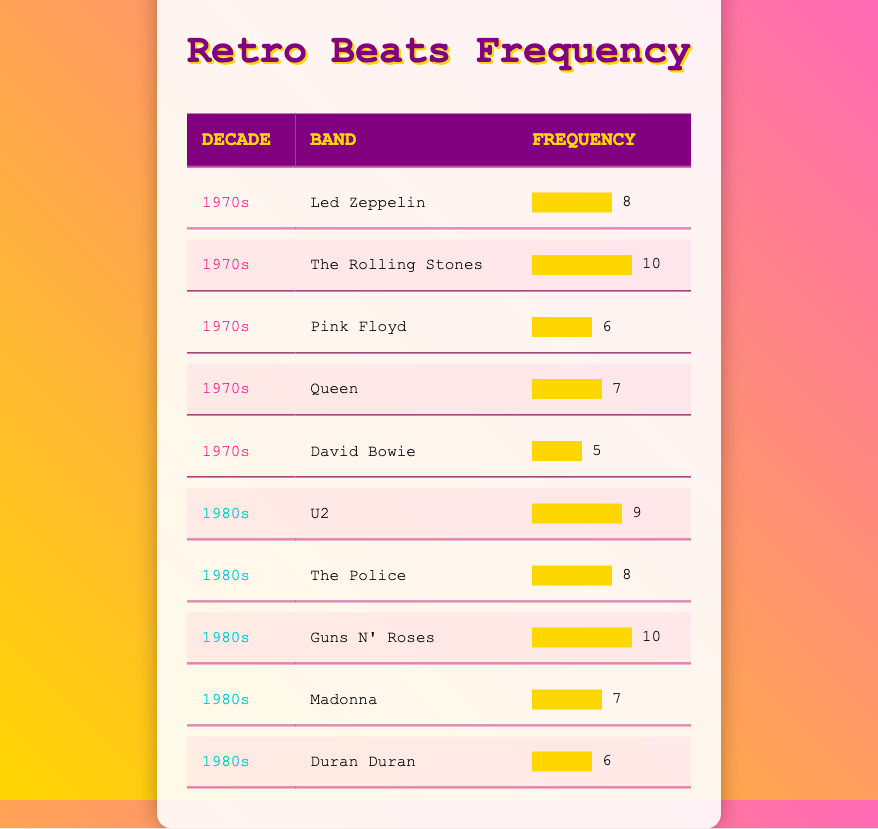What is the band with the highest frequency in the 1970s? In the 1970s section of the table, I can see that The Rolling Stones has the highest frequency value of 10.
Answer: The Rolling Stones How many bands from the 1980s have a frequency of 7 or more? The bands from the 1980s listed are U2, The Police, Guns N' Roses, Madonna, and Duran Duran. Among these, U2 (9), The Police (8), Guns N' Roses (10), and Madonna (7) have frequencies of 7 or more. That's a total of 4 bands.
Answer: 4 Which decade has more bands with a frequency of 6 or higher? From the 1970s, Led Zeppelin (8), The Rolling Stones (10), Pink Floyd (6), Queen (7), and David Bowie (5) give us 4 bands with 6 or higher. For the 1980s, U2 (9), The Police (8), Guns N' Roses (10), Madonna (7), and Duran Duran (6) also yields 5 bands. Thus, the 1980s have more bands with a frequency of 6 or higher.
Answer: The 1980s Is there a band from the 1970s with the same frequency as any band from the 1980s? The 1970s have Led Zeppelin (8), The Rolling Stones (10), Pink Floyd (6), Queen (7), and David Bowie (5). The 1980s have U2 (9), The Police (8), Guns N' Roses (10), Madonna (7), and Duran Duran (6). Notably, Led Zeppelin and The Police both have a frequency of 8, and The Rolling Stones and Guns N' Roses both have a frequency of 10. Therefore, there are indeed matches.
Answer: Yes What is the total frequency of all the bands from the 1970s? To find the total frequency of all bands in the 1970s, I sum Led Zeppelin (8), The Rolling Stones (10), Pink Floyd (6), Queen (7), and David Bowie (5). The total is 8 + 10 + 6 + 7 + 5 = 36.
Answer: 36 Which band from the 1980s has the lowest frequency? Investigating the 1980s section, I see the bands listed are U2 (9), The Police (8), Guns N' Roses (10), Madonna (7), and Duran Duran (6). The band with the lowest frequency among them is Duran Duran, which has a frequency of 6.
Answer: Duran Duran How many overall frequencies from both decades are above 8? Summing up the frequencies for both decades, from the 1970s: The Rolling Stones (10), Led Zeppelin (8), and Queen (7) show 2 frequencies above 8. In the 1980s, U2 (9) and Guns N' Roses (10) also show 2 frequencies above 8. Therefore, the total from both decades is 4.
Answer: 4 What is the average frequency of the bands in the 1980s? To find the average frequency of the 1980s bands, I sum their frequencies: U2 (9), The Police (8), Guns N' Roses (10), Madonna (7), and Duran Duran (6). The total is 9 + 8 + 10 + 7 + 6 = 40. There are 5 bands, so I divide the total frequency by the number of bands: 40 / 5 = 8.
Answer: 8 